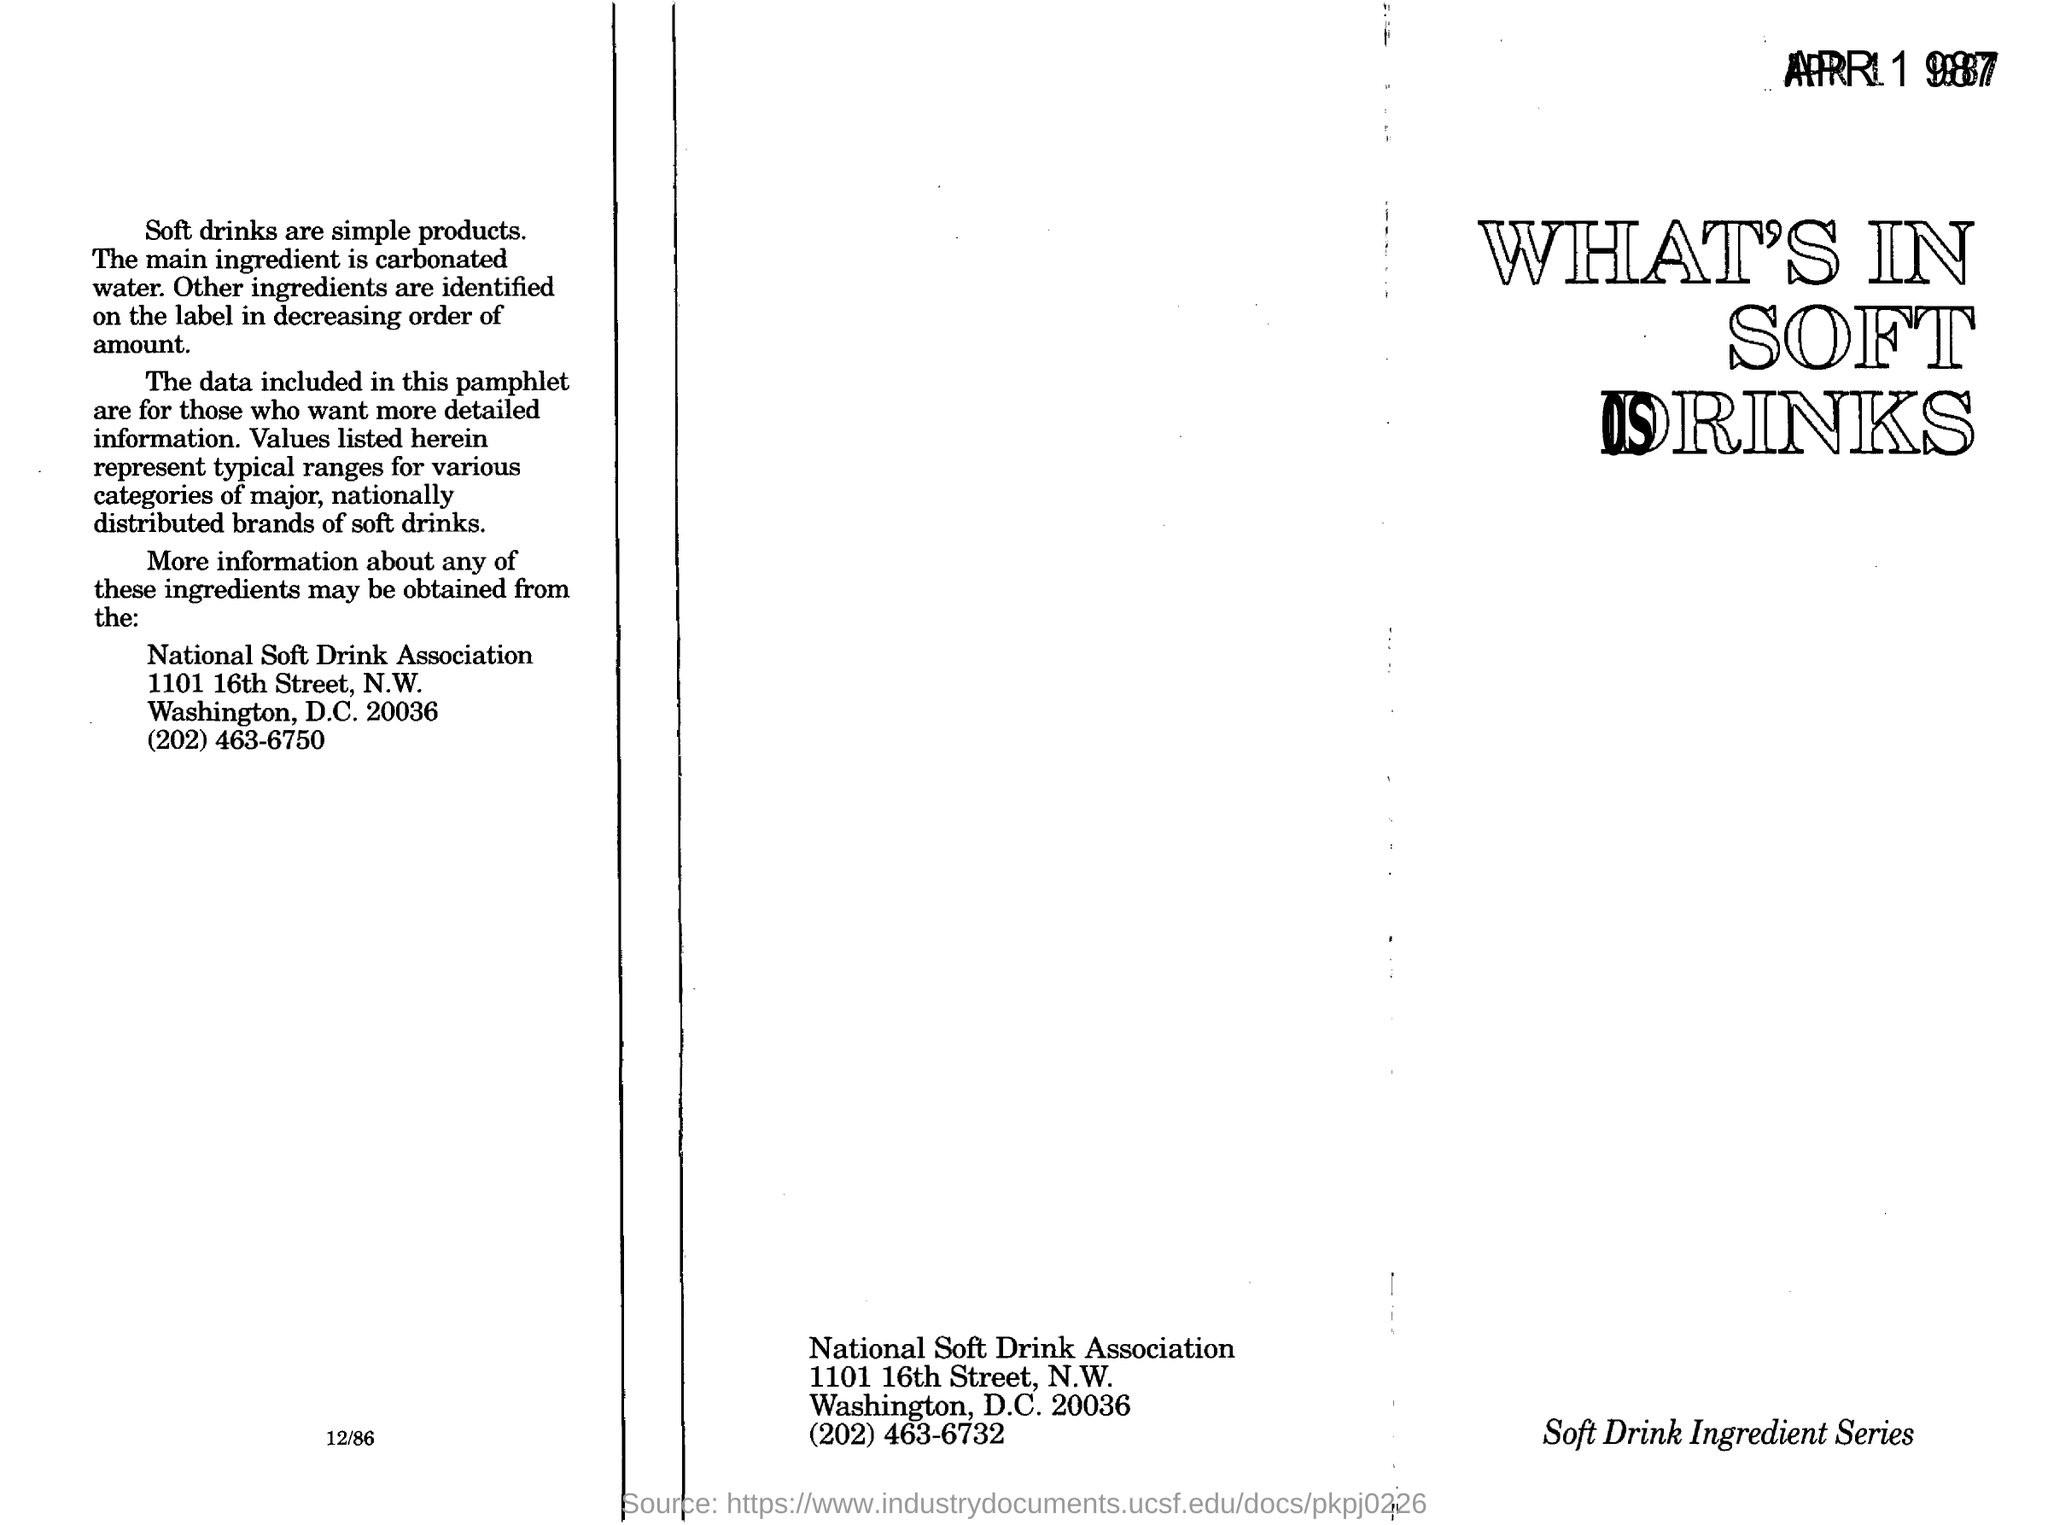Identify some key points in this picture. What is the heading in the right corner, and what is contained in Soft Drinks? The main ingredient in soft drinks is carbonated water. 